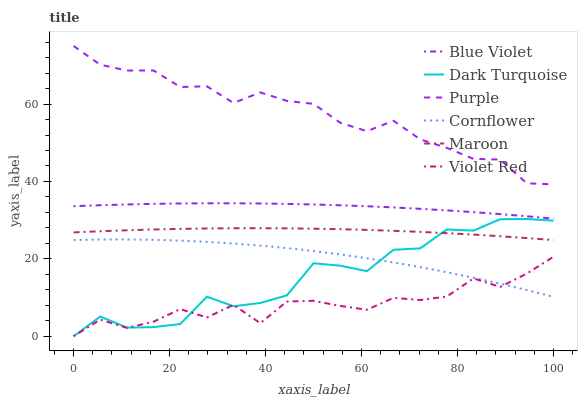Does Violet Red have the minimum area under the curve?
Answer yes or no. Yes. Does Purple have the maximum area under the curve?
Answer yes or no. Yes. Does Purple have the minimum area under the curve?
Answer yes or no. No. Does Violet Red have the maximum area under the curve?
Answer yes or no. No. Is Maroon the smoothest?
Answer yes or no. Yes. Is Dark Turquoise the roughest?
Answer yes or no. Yes. Is Violet Red the smoothest?
Answer yes or no. No. Is Violet Red the roughest?
Answer yes or no. No. Does Violet Red have the lowest value?
Answer yes or no. Yes. Does Purple have the lowest value?
Answer yes or no. No. Does Purple have the highest value?
Answer yes or no. Yes. Does Violet Red have the highest value?
Answer yes or no. No. Is Cornflower less than Purple?
Answer yes or no. Yes. Is Purple greater than Dark Turquoise?
Answer yes or no. Yes. Does Dark Turquoise intersect Violet Red?
Answer yes or no. Yes. Is Dark Turquoise less than Violet Red?
Answer yes or no. No. Is Dark Turquoise greater than Violet Red?
Answer yes or no. No. Does Cornflower intersect Purple?
Answer yes or no. No. 